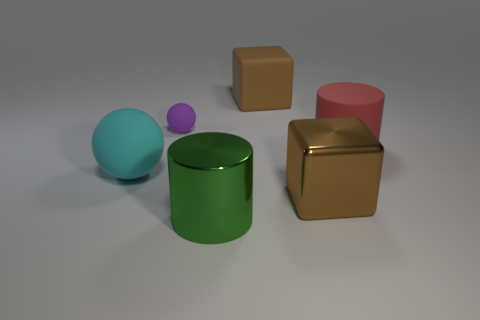Add 1 small metal objects. How many objects exist? 7 Subtract all balls. How many objects are left? 4 Subtract 1 green cylinders. How many objects are left? 5 Subtract all tiny brown metal cylinders. Subtract all large shiny cylinders. How many objects are left? 5 Add 3 matte cylinders. How many matte cylinders are left? 4 Add 5 purple things. How many purple things exist? 6 